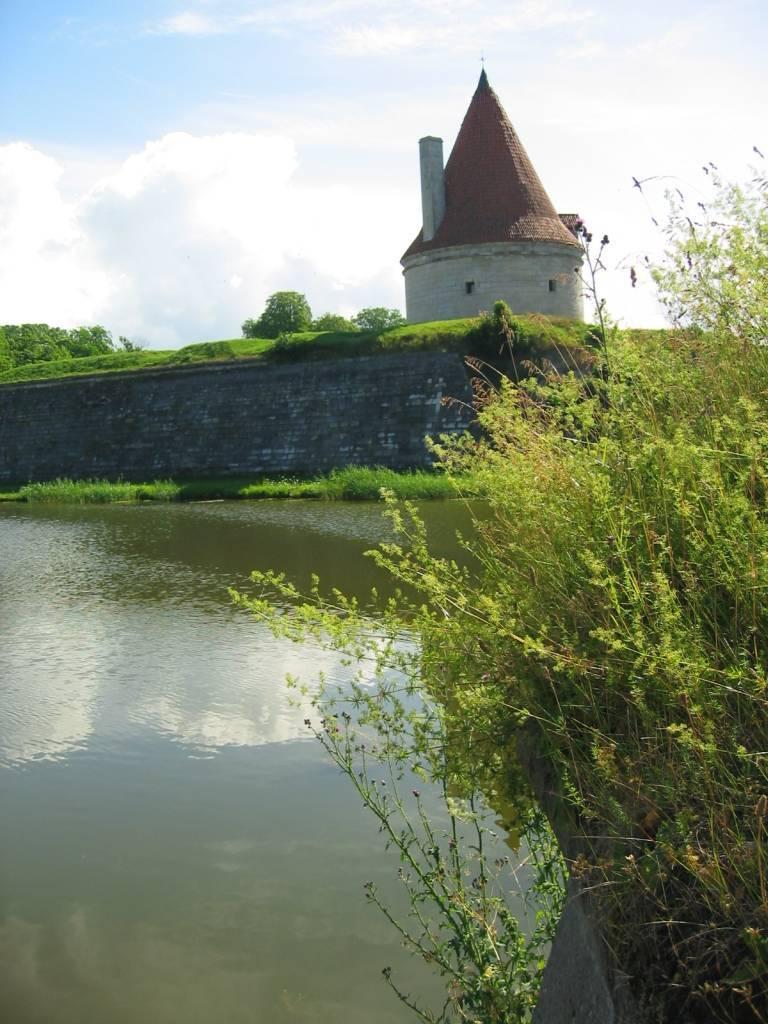Please provide a concise description of this image. In this picture there is a building behind the wall. At the back there are trees. At the top there is sky and there are clouds. At the bottom there is water and in the foreground there is a tree. 